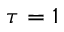<formula> <loc_0><loc_0><loc_500><loc_500>\tau = 1</formula> 